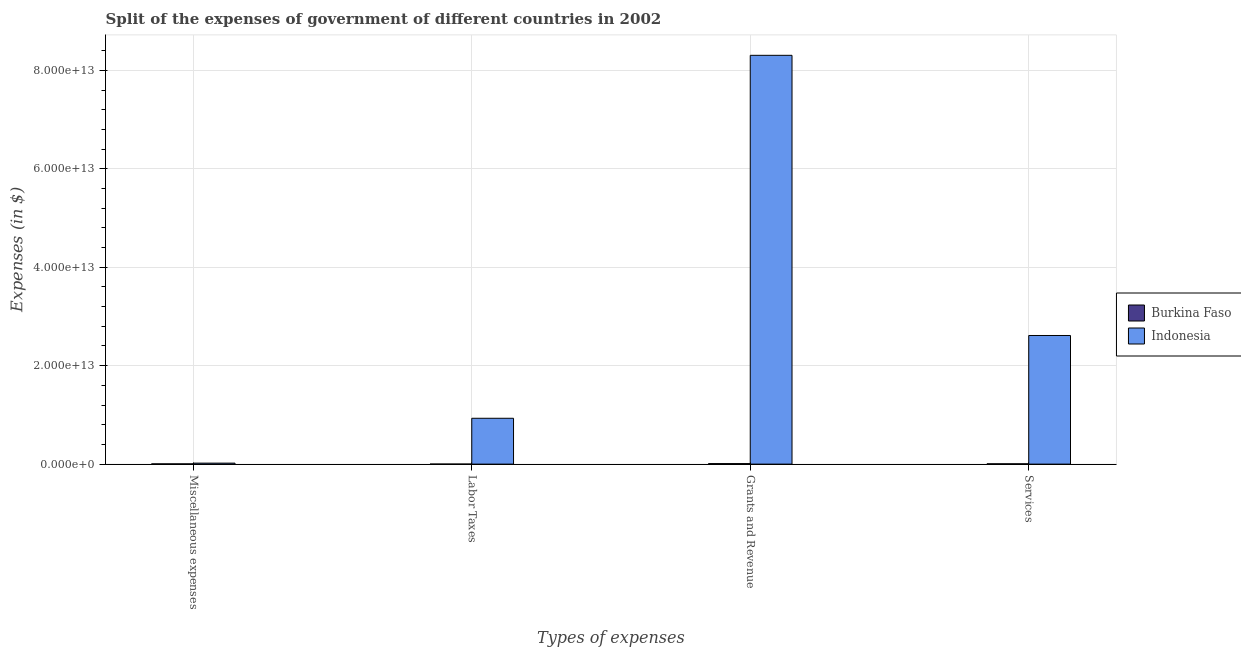How many groups of bars are there?
Your answer should be compact. 4. What is the label of the 3rd group of bars from the left?
Provide a short and direct response. Grants and Revenue. What is the amount spent on miscellaneous expenses in Burkina Faso?
Make the answer very short. 4.83e+1. Across all countries, what is the maximum amount spent on grants and revenue?
Provide a succinct answer. 8.31e+13. Across all countries, what is the minimum amount spent on labor taxes?
Offer a terse response. 6.63e+09. In which country was the amount spent on miscellaneous expenses minimum?
Give a very brief answer. Burkina Faso. What is the total amount spent on labor taxes in the graph?
Offer a very short reply. 9.32e+12. What is the difference between the amount spent on labor taxes in Indonesia and that in Burkina Faso?
Provide a succinct answer. 9.31e+12. What is the difference between the amount spent on miscellaneous expenses in Burkina Faso and the amount spent on grants and revenue in Indonesia?
Provide a succinct answer. -8.30e+13. What is the average amount spent on services per country?
Offer a terse response. 1.31e+13. What is the difference between the amount spent on grants and revenue and amount spent on miscellaneous expenses in Indonesia?
Keep it short and to the point. 8.29e+13. In how many countries, is the amount spent on grants and revenue greater than 60000000000000 $?
Your response must be concise. 1. What is the ratio of the amount spent on labor taxes in Burkina Faso to that in Indonesia?
Give a very brief answer. 0. Is the amount spent on miscellaneous expenses in Burkina Faso less than that in Indonesia?
Ensure brevity in your answer.  Yes. Is the difference between the amount spent on labor taxes in Burkina Faso and Indonesia greater than the difference between the amount spent on services in Burkina Faso and Indonesia?
Ensure brevity in your answer.  Yes. What is the difference between the highest and the second highest amount spent on miscellaneous expenses?
Offer a terse response. 1.52e+11. What is the difference between the highest and the lowest amount spent on miscellaneous expenses?
Ensure brevity in your answer.  1.52e+11. In how many countries, is the amount spent on labor taxes greater than the average amount spent on labor taxes taken over all countries?
Make the answer very short. 1. What does the 2nd bar from the left in Miscellaneous expenses represents?
Your response must be concise. Indonesia. What does the 2nd bar from the right in Services represents?
Make the answer very short. Burkina Faso. Is it the case that in every country, the sum of the amount spent on miscellaneous expenses and amount spent on labor taxes is greater than the amount spent on grants and revenue?
Your response must be concise. No. How many countries are there in the graph?
Offer a very short reply. 2. What is the difference between two consecutive major ticks on the Y-axis?
Provide a succinct answer. 2.00e+13. Does the graph contain any zero values?
Offer a very short reply. No. Where does the legend appear in the graph?
Offer a very short reply. Center right. How are the legend labels stacked?
Provide a short and direct response. Vertical. What is the title of the graph?
Provide a short and direct response. Split of the expenses of government of different countries in 2002. Does "West Bank and Gaza" appear as one of the legend labels in the graph?
Make the answer very short. No. What is the label or title of the X-axis?
Your answer should be very brief. Types of expenses. What is the label or title of the Y-axis?
Provide a succinct answer. Expenses (in $). What is the Expenses (in $) of Burkina Faso in Miscellaneous expenses?
Your answer should be very brief. 4.83e+1. What is the Expenses (in $) of Indonesia in Miscellaneous expenses?
Your response must be concise. 2.01e+11. What is the Expenses (in $) in Burkina Faso in Labor Taxes?
Your answer should be very brief. 6.63e+09. What is the Expenses (in $) in Indonesia in Labor Taxes?
Make the answer very short. 9.31e+12. What is the Expenses (in $) in Burkina Faso in Grants and Revenue?
Ensure brevity in your answer.  1.06e+11. What is the Expenses (in $) of Indonesia in Grants and Revenue?
Give a very brief answer. 8.31e+13. What is the Expenses (in $) in Burkina Faso in Services?
Your answer should be compact. 6.25e+1. What is the Expenses (in $) in Indonesia in Services?
Provide a short and direct response. 2.61e+13. Across all Types of expenses, what is the maximum Expenses (in $) of Burkina Faso?
Provide a succinct answer. 1.06e+11. Across all Types of expenses, what is the maximum Expenses (in $) in Indonesia?
Offer a very short reply. 8.31e+13. Across all Types of expenses, what is the minimum Expenses (in $) of Burkina Faso?
Your response must be concise. 6.63e+09. Across all Types of expenses, what is the minimum Expenses (in $) in Indonesia?
Provide a succinct answer. 2.01e+11. What is the total Expenses (in $) of Burkina Faso in the graph?
Make the answer very short. 2.23e+11. What is the total Expenses (in $) in Indonesia in the graph?
Your answer should be very brief. 1.19e+14. What is the difference between the Expenses (in $) in Burkina Faso in Miscellaneous expenses and that in Labor Taxes?
Give a very brief answer. 4.17e+1. What is the difference between the Expenses (in $) in Indonesia in Miscellaneous expenses and that in Labor Taxes?
Your response must be concise. -9.11e+12. What is the difference between the Expenses (in $) in Burkina Faso in Miscellaneous expenses and that in Grants and Revenue?
Offer a very short reply. -5.73e+1. What is the difference between the Expenses (in $) in Indonesia in Miscellaneous expenses and that in Grants and Revenue?
Your answer should be compact. -8.29e+13. What is the difference between the Expenses (in $) of Burkina Faso in Miscellaneous expenses and that in Services?
Offer a very short reply. -1.42e+1. What is the difference between the Expenses (in $) in Indonesia in Miscellaneous expenses and that in Services?
Give a very brief answer. -2.59e+13. What is the difference between the Expenses (in $) in Burkina Faso in Labor Taxes and that in Grants and Revenue?
Provide a succinct answer. -9.89e+1. What is the difference between the Expenses (in $) in Indonesia in Labor Taxes and that in Grants and Revenue?
Ensure brevity in your answer.  -7.37e+13. What is the difference between the Expenses (in $) in Burkina Faso in Labor Taxes and that in Services?
Your answer should be compact. -5.59e+1. What is the difference between the Expenses (in $) in Indonesia in Labor Taxes and that in Services?
Offer a very short reply. -1.68e+13. What is the difference between the Expenses (in $) of Burkina Faso in Grants and Revenue and that in Services?
Make the answer very short. 4.31e+1. What is the difference between the Expenses (in $) in Indonesia in Grants and Revenue and that in Services?
Provide a succinct answer. 5.69e+13. What is the difference between the Expenses (in $) in Burkina Faso in Miscellaneous expenses and the Expenses (in $) in Indonesia in Labor Taxes?
Ensure brevity in your answer.  -9.27e+12. What is the difference between the Expenses (in $) of Burkina Faso in Miscellaneous expenses and the Expenses (in $) of Indonesia in Grants and Revenue?
Provide a short and direct response. -8.30e+13. What is the difference between the Expenses (in $) of Burkina Faso in Miscellaneous expenses and the Expenses (in $) of Indonesia in Services?
Your answer should be compact. -2.61e+13. What is the difference between the Expenses (in $) of Burkina Faso in Labor Taxes and the Expenses (in $) of Indonesia in Grants and Revenue?
Give a very brief answer. -8.30e+13. What is the difference between the Expenses (in $) of Burkina Faso in Labor Taxes and the Expenses (in $) of Indonesia in Services?
Make the answer very short. -2.61e+13. What is the difference between the Expenses (in $) of Burkina Faso in Grants and Revenue and the Expenses (in $) of Indonesia in Services?
Offer a terse response. -2.60e+13. What is the average Expenses (in $) in Burkina Faso per Types of expenses?
Give a very brief answer. 5.57e+1. What is the average Expenses (in $) in Indonesia per Types of expenses?
Your answer should be very brief. 2.97e+13. What is the difference between the Expenses (in $) of Burkina Faso and Expenses (in $) of Indonesia in Miscellaneous expenses?
Provide a succinct answer. -1.52e+11. What is the difference between the Expenses (in $) in Burkina Faso and Expenses (in $) in Indonesia in Labor Taxes?
Your answer should be very brief. -9.31e+12. What is the difference between the Expenses (in $) in Burkina Faso and Expenses (in $) in Indonesia in Grants and Revenue?
Give a very brief answer. -8.29e+13. What is the difference between the Expenses (in $) in Burkina Faso and Expenses (in $) in Indonesia in Services?
Provide a short and direct response. -2.61e+13. What is the ratio of the Expenses (in $) in Burkina Faso in Miscellaneous expenses to that in Labor Taxes?
Provide a succinct answer. 7.28. What is the ratio of the Expenses (in $) in Indonesia in Miscellaneous expenses to that in Labor Taxes?
Your answer should be compact. 0.02. What is the ratio of the Expenses (in $) in Burkina Faso in Miscellaneous expenses to that in Grants and Revenue?
Your answer should be very brief. 0.46. What is the ratio of the Expenses (in $) of Indonesia in Miscellaneous expenses to that in Grants and Revenue?
Offer a very short reply. 0. What is the ratio of the Expenses (in $) of Burkina Faso in Miscellaneous expenses to that in Services?
Offer a terse response. 0.77. What is the ratio of the Expenses (in $) in Indonesia in Miscellaneous expenses to that in Services?
Ensure brevity in your answer.  0.01. What is the ratio of the Expenses (in $) in Burkina Faso in Labor Taxes to that in Grants and Revenue?
Offer a terse response. 0.06. What is the ratio of the Expenses (in $) of Indonesia in Labor Taxes to that in Grants and Revenue?
Make the answer very short. 0.11. What is the ratio of the Expenses (in $) in Burkina Faso in Labor Taxes to that in Services?
Ensure brevity in your answer.  0.11. What is the ratio of the Expenses (in $) of Indonesia in Labor Taxes to that in Services?
Offer a very short reply. 0.36. What is the ratio of the Expenses (in $) in Burkina Faso in Grants and Revenue to that in Services?
Offer a very short reply. 1.69. What is the ratio of the Expenses (in $) of Indonesia in Grants and Revenue to that in Services?
Keep it short and to the point. 3.18. What is the difference between the highest and the second highest Expenses (in $) in Burkina Faso?
Keep it short and to the point. 4.31e+1. What is the difference between the highest and the second highest Expenses (in $) in Indonesia?
Keep it short and to the point. 5.69e+13. What is the difference between the highest and the lowest Expenses (in $) in Burkina Faso?
Your answer should be very brief. 9.89e+1. What is the difference between the highest and the lowest Expenses (in $) in Indonesia?
Your answer should be compact. 8.29e+13. 